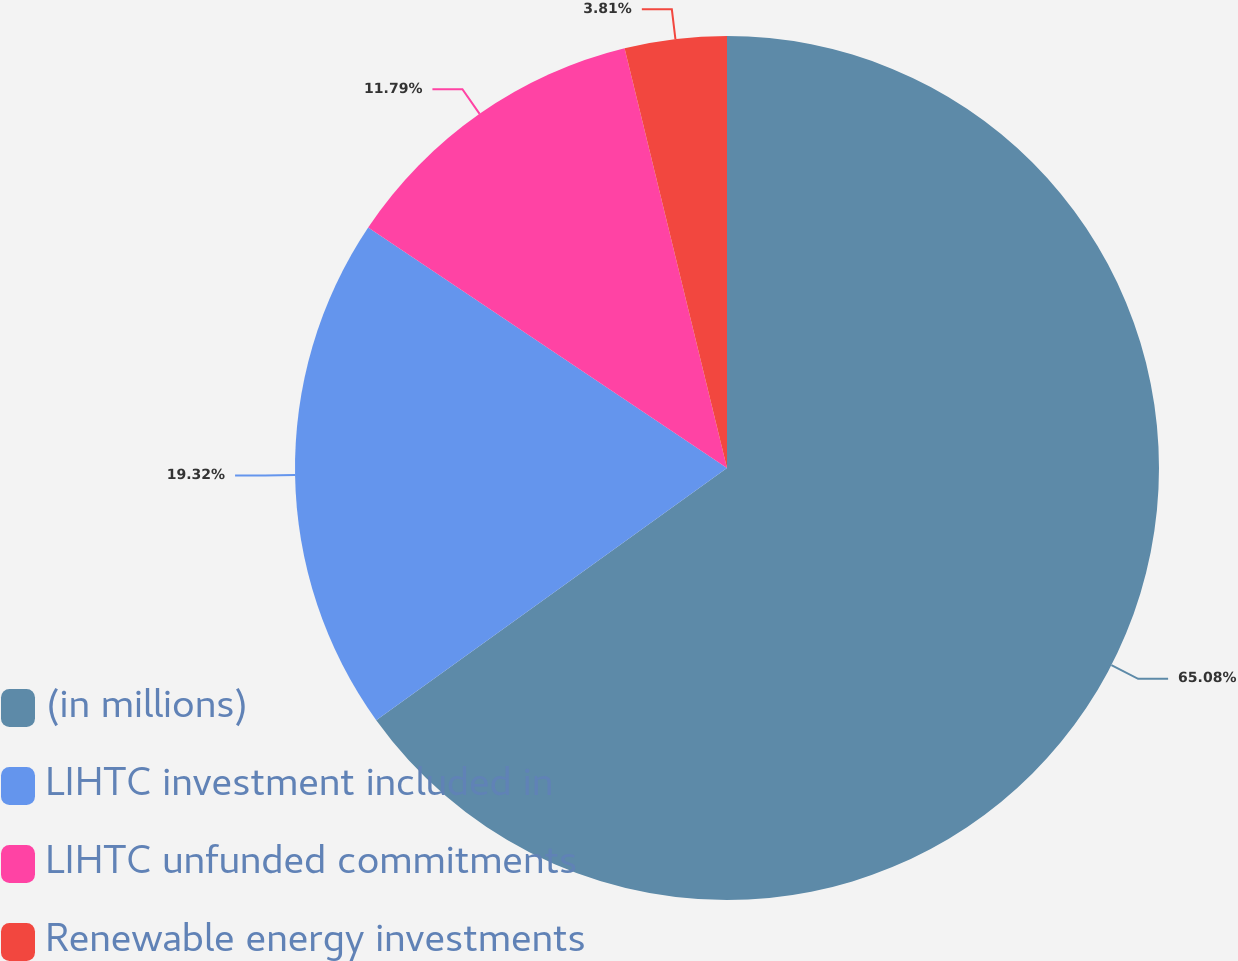Convert chart. <chart><loc_0><loc_0><loc_500><loc_500><pie_chart><fcel>(in millions)<fcel>LIHTC investment included in<fcel>LIHTC unfunded commitments<fcel>Renewable energy investments<nl><fcel>65.08%<fcel>19.32%<fcel>11.79%<fcel>3.81%<nl></chart> 